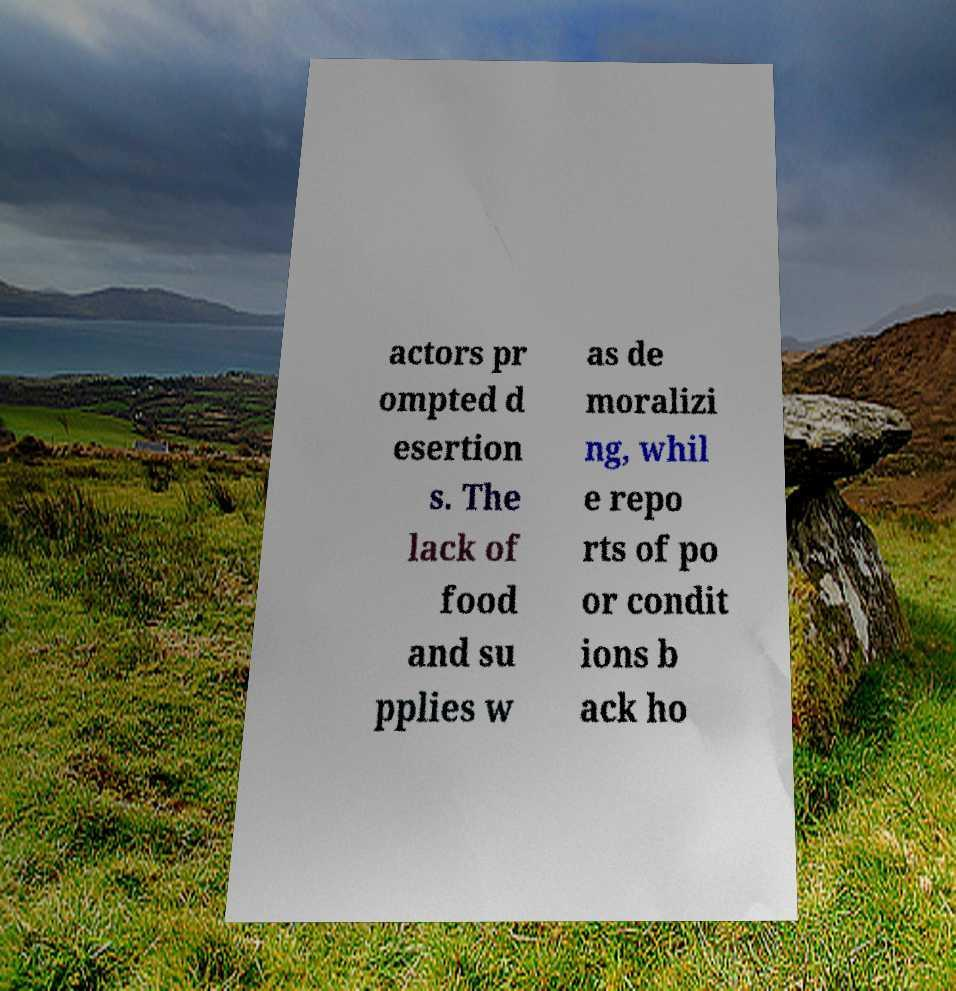Please identify and transcribe the text found in this image. actors pr ompted d esertion s. The lack of food and su pplies w as de moralizi ng, whil e repo rts of po or condit ions b ack ho 